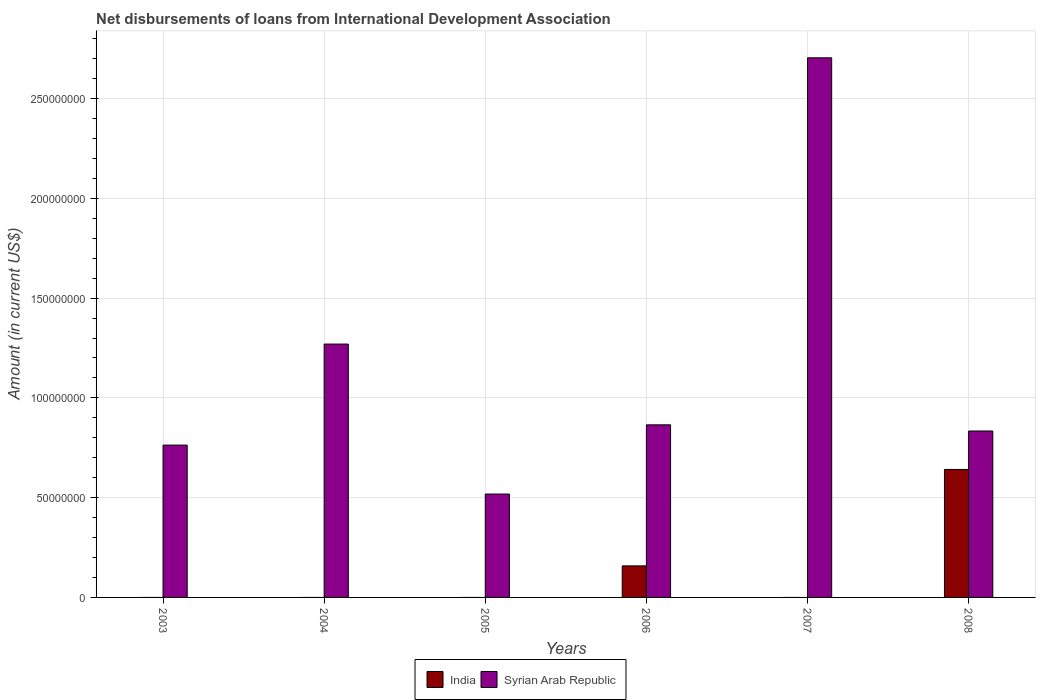How many different coloured bars are there?
Give a very brief answer. 2. Are the number of bars on each tick of the X-axis equal?
Give a very brief answer. No. How many bars are there on the 1st tick from the left?
Give a very brief answer. 1. How many bars are there on the 2nd tick from the right?
Offer a terse response. 1. In how many cases, is the number of bars for a given year not equal to the number of legend labels?
Offer a very short reply. 4. What is the amount of loans disbursed in India in 2006?
Your response must be concise. 1.58e+07. Across all years, what is the maximum amount of loans disbursed in Syrian Arab Republic?
Offer a very short reply. 2.70e+08. Across all years, what is the minimum amount of loans disbursed in Syrian Arab Republic?
Your answer should be compact. 5.18e+07. In which year was the amount of loans disbursed in Syrian Arab Republic maximum?
Offer a very short reply. 2007. What is the total amount of loans disbursed in Syrian Arab Republic in the graph?
Your response must be concise. 6.95e+08. What is the difference between the amount of loans disbursed in Syrian Arab Republic in 2004 and that in 2008?
Provide a succinct answer. 4.36e+07. What is the difference between the amount of loans disbursed in Syrian Arab Republic in 2003 and the amount of loans disbursed in India in 2004?
Offer a terse response. 7.63e+07. What is the average amount of loans disbursed in India per year?
Your response must be concise. 1.33e+07. In the year 2006, what is the difference between the amount of loans disbursed in India and amount of loans disbursed in Syrian Arab Republic?
Your answer should be compact. -7.07e+07. What is the ratio of the amount of loans disbursed in Syrian Arab Republic in 2003 to that in 2006?
Offer a terse response. 0.88. Is the amount of loans disbursed in Syrian Arab Republic in 2003 less than that in 2006?
Offer a terse response. Yes. What is the difference between the highest and the second highest amount of loans disbursed in Syrian Arab Republic?
Give a very brief answer. 1.43e+08. What is the difference between the highest and the lowest amount of loans disbursed in Syrian Arab Republic?
Ensure brevity in your answer.  2.19e+08. Is the sum of the amount of loans disbursed in Syrian Arab Republic in 2005 and 2007 greater than the maximum amount of loans disbursed in India across all years?
Provide a short and direct response. Yes. How many bars are there?
Your answer should be compact. 8. How many years are there in the graph?
Your response must be concise. 6. What is the difference between two consecutive major ticks on the Y-axis?
Make the answer very short. 5.00e+07. Does the graph contain any zero values?
Your answer should be very brief. Yes. Does the graph contain grids?
Keep it short and to the point. Yes. Where does the legend appear in the graph?
Your answer should be compact. Bottom center. How many legend labels are there?
Keep it short and to the point. 2. How are the legend labels stacked?
Offer a terse response. Horizontal. What is the title of the graph?
Offer a terse response. Net disbursements of loans from International Development Association. Does "Austria" appear as one of the legend labels in the graph?
Offer a very short reply. No. What is the label or title of the Y-axis?
Offer a very short reply. Amount (in current US$). What is the Amount (in current US$) in Syrian Arab Republic in 2003?
Ensure brevity in your answer.  7.63e+07. What is the Amount (in current US$) in India in 2004?
Make the answer very short. 0. What is the Amount (in current US$) of Syrian Arab Republic in 2004?
Make the answer very short. 1.27e+08. What is the Amount (in current US$) in India in 2005?
Your response must be concise. 0. What is the Amount (in current US$) in Syrian Arab Republic in 2005?
Your answer should be compact. 5.18e+07. What is the Amount (in current US$) of India in 2006?
Your answer should be very brief. 1.58e+07. What is the Amount (in current US$) of Syrian Arab Republic in 2006?
Keep it short and to the point. 8.65e+07. What is the Amount (in current US$) in India in 2007?
Your response must be concise. 0. What is the Amount (in current US$) in Syrian Arab Republic in 2007?
Give a very brief answer. 2.70e+08. What is the Amount (in current US$) of India in 2008?
Ensure brevity in your answer.  6.41e+07. What is the Amount (in current US$) in Syrian Arab Republic in 2008?
Give a very brief answer. 8.34e+07. Across all years, what is the maximum Amount (in current US$) of India?
Ensure brevity in your answer.  6.41e+07. Across all years, what is the maximum Amount (in current US$) in Syrian Arab Republic?
Your answer should be very brief. 2.70e+08. Across all years, what is the minimum Amount (in current US$) in Syrian Arab Republic?
Offer a very short reply. 5.18e+07. What is the total Amount (in current US$) in India in the graph?
Provide a short and direct response. 7.99e+07. What is the total Amount (in current US$) of Syrian Arab Republic in the graph?
Provide a short and direct response. 6.95e+08. What is the difference between the Amount (in current US$) in Syrian Arab Republic in 2003 and that in 2004?
Your response must be concise. -5.06e+07. What is the difference between the Amount (in current US$) in Syrian Arab Republic in 2003 and that in 2005?
Your response must be concise. 2.45e+07. What is the difference between the Amount (in current US$) of Syrian Arab Republic in 2003 and that in 2006?
Provide a succinct answer. -1.02e+07. What is the difference between the Amount (in current US$) of Syrian Arab Republic in 2003 and that in 2007?
Your response must be concise. -1.94e+08. What is the difference between the Amount (in current US$) of Syrian Arab Republic in 2003 and that in 2008?
Provide a short and direct response. -7.06e+06. What is the difference between the Amount (in current US$) in Syrian Arab Republic in 2004 and that in 2005?
Provide a short and direct response. 7.52e+07. What is the difference between the Amount (in current US$) of Syrian Arab Republic in 2004 and that in 2006?
Ensure brevity in your answer.  4.05e+07. What is the difference between the Amount (in current US$) of Syrian Arab Republic in 2004 and that in 2007?
Offer a very short reply. -1.43e+08. What is the difference between the Amount (in current US$) of Syrian Arab Republic in 2004 and that in 2008?
Provide a short and direct response. 4.36e+07. What is the difference between the Amount (in current US$) of Syrian Arab Republic in 2005 and that in 2006?
Offer a terse response. -3.47e+07. What is the difference between the Amount (in current US$) in Syrian Arab Republic in 2005 and that in 2007?
Your response must be concise. -2.19e+08. What is the difference between the Amount (in current US$) in Syrian Arab Republic in 2005 and that in 2008?
Your answer should be very brief. -3.16e+07. What is the difference between the Amount (in current US$) of Syrian Arab Republic in 2006 and that in 2007?
Your answer should be very brief. -1.84e+08. What is the difference between the Amount (in current US$) in India in 2006 and that in 2008?
Your response must be concise. -4.83e+07. What is the difference between the Amount (in current US$) in Syrian Arab Republic in 2006 and that in 2008?
Offer a very short reply. 3.10e+06. What is the difference between the Amount (in current US$) in Syrian Arab Republic in 2007 and that in 2008?
Provide a short and direct response. 1.87e+08. What is the difference between the Amount (in current US$) of India in 2006 and the Amount (in current US$) of Syrian Arab Republic in 2007?
Your answer should be compact. -2.55e+08. What is the difference between the Amount (in current US$) of India in 2006 and the Amount (in current US$) of Syrian Arab Republic in 2008?
Your answer should be compact. -6.76e+07. What is the average Amount (in current US$) of India per year?
Keep it short and to the point. 1.33e+07. What is the average Amount (in current US$) in Syrian Arab Republic per year?
Your answer should be compact. 1.16e+08. In the year 2006, what is the difference between the Amount (in current US$) of India and Amount (in current US$) of Syrian Arab Republic?
Keep it short and to the point. -7.07e+07. In the year 2008, what is the difference between the Amount (in current US$) of India and Amount (in current US$) of Syrian Arab Republic?
Ensure brevity in your answer.  -1.93e+07. What is the ratio of the Amount (in current US$) in Syrian Arab Republic in 2003 to that in 2004?
Give a very brief answer. 0.6. What is the ratio of the Amount (in current US$) of Syrian Arab Republic in 2003 to that in 2005?
Offer a very short reply. 1.47. What is the ratio of the Amount (in current US$) of Syrian Arab Republic in 2003 to that in 2006?
Ensure brevity in your answer.  0.88. What is the ratio of the Amount (in current US$) in Syrian Arab Republic in 2003 to that in 2007?
Ensure brevity in your answer.  0.28. What is the ratio of the Amount (in current US$) of Syrian Arab Republic in 2003 to that in 2008?
Provide a succinct answer. 0.92. What is the ratio of the Amount (in current US$) in Syrian Arab Republic in 2004 to that in 2005?
Ensure brevity in your answer.  2.45. What is the ratio of the Amount (in current US$) in Syrian Arab Republic in 2004 to that in 2006?
Make the answer very short. 1.47. What is the ratio of the Amount (in current US$) in Syrian Arab Republic in 2004 to that in 2007?
Provide a short and direct response. 0.47. What is the ratio of the Amount (in current US$) of Syrian Arab Republic in 2004 to that in 2008?
Offer a very short reply. 1.52. What is the ratio of the Amount (in current US$) of Syrian Arab Republic in 2005 to that in 2006?
Your response must be concise. 0.6. What is the ratio of the Amount (in current US$) of Syrian Arab Republic in 2005 to that in 2007?
Offer a terse response. 0.19. What is the ratio of the Amount (in current US$) in Syrian Arab Republic in 2005 to that in 2008?
Your answer should be very brief. 0.62. What is the ratio of the Amount (in current US$) in Syrian Arab Republic in 2006 to that in 2007?
Give a very brief answer. 0.32. What is the ratio of the Amount (in current US$) of India in 2006 to that in 2008?
Ensure brevity in your answer.  0.25. What is the ratio of the Amount (in current US$) of Syrian Arab Republic in 2006 to that in 2008?
Give a very brief answer. 1.04. What is the ratio of the Amount (in current US$) in Syrian Arab Republic in 2007 to that in 2008?
Keep it short and to the point. 3.24. What is the difference between the highest and the second highest Amount (in current US$) of Syrian Arab Republic?
Offer a very short reply. 1.43e+08. What is the difference between the highest and the lowest Amount (in current US$) in India?
Offer a very short reply. 6.41e+07. What is the difference between the highest and the lowest Amount (in current US$) in Syrian Arab Republic?
Provide a short and direct response. 2.19e+08. 